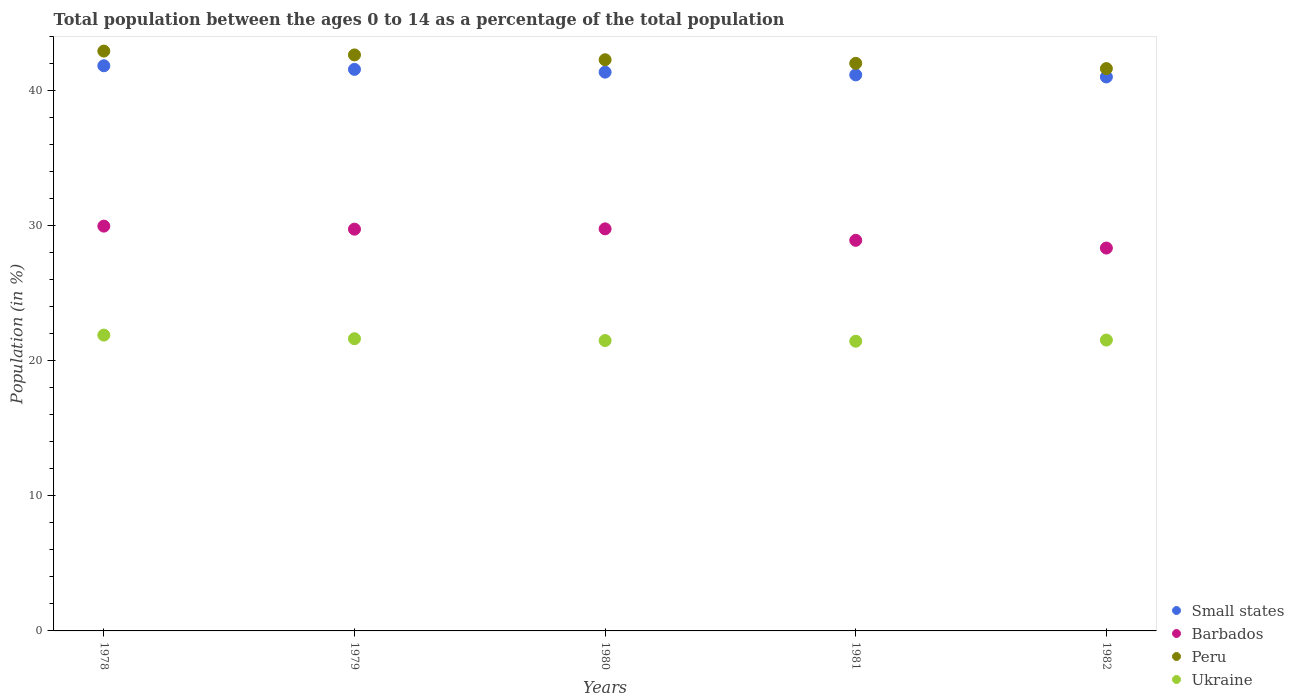How many different coloured dotlines are there?
Provide a short and direct response. 4. What is the percentage of the population ages 0 to 14 in Ukraine in 1981?
Your answer should be very brief. 21.45. Across all years, what is the maximum percentage of the population ages 0 to 14 in Barbados?
Your answer should be very brief. 29.98. Across all years, what is the minimum percentage of the population ages 0 to 14 in Peru?
Ensure brevity in your answer.  41.64. In which year was the percentage of the population ages 0 to 14 in Barbados maximum?
Offer a terse response. 1978. What is the total percentage of the population ages 0 to 14 in Small states in the graph?
Offer a terse response. 207.01. What is the difference between the percentage of the population ages 0 to 14 in Barbados in 1980 and that in 1981?
Offer a terse response. 0.85. What is the difference between the percentage of the population ages 0 to 14 in Small states in 1980 and the percentage of the population ages 0 to 14 in Ukraine in 1982?
Provide a succinct answer. 19.84. What is the average percentage of the population ages 0 to 14 in Peru per year?
Your answer should be very brief. 42.31. In the year 1980, what is the difference between the percentage of the population ages 0 to 14 in Small states and percentage of the population ages 0 to 14 in Peru?
Your answer should be very brief. -0.92. In how many years, is the percentage of the population ages 0 to 14 in Barbados greater than 16?
Provide a short and direct response. 5. What is the ratio of the percentage of the population ages 0 to 14 in Peru in 1980 to that in 1982?
Provide a succinct answer. 1.02. Is the percentage of the population ages 0 to 14 in Ukraine in 1979 less than that in 1980?
Ensure brevity in your answer.  No. Is the difference between the percentage of the population ages 0 to 14 in Small states in 1980 and 1982 greater than the difference between the percentage of the population ages 0 to 14 in Peru in 1980 and 1982?
Make the answer very short. No. What is the difference between the highest and the second highest percentage of the population ages 0 to 14 in Ukraine?
Offer a terse response. 0.27. What is the difference between the highest and the lowest percentage of the population ages 0 to 14 in Barbados?
Make the answer very short. 1.62. Is the sum of the percentage of the population ages 0 to 14 in Small states in 1978 and 1979 greater than the maximum percentage of the population ages 0 to 14 in Ukraine across all years?
Offer a terse response. Yes. Does the percentage of the population ages 0 to 14 in Small states monotonically increase over the years?
Your response must be concise. No. Is the percentage of the population ages 0 to 14 in Barbados strictly greater than the percentage of the population ages 0 to 14 in Ukraine over the years?
Offer a very short reply. Yes. Is the percentage of the population ages 0 to 14 in Peru strictly less than the percentage of the population ages 0 to 14 in Small states over the years?
Your answer should be compact. No. How many dotlines are there?
Ensure brevity in your answer.  4. How many years are there in the graph?
Keep it short and to the point. 5. What is the difference between two consecutive major ticks on the Y-axis?
Your answer should be compact. 10. Does the graph contain any zero values?
Offer a terse response. No. What is the title of the graph?
Your answer should be very brief. Total population between the ages 0 to 14 as a percentage of the total population. What is the label or title of the X-axis?
Offer a very short reply. Years. What is the label or title of the Y-axis?
Make the answer very short. Population (in %). What is the Population (in %) of Small states in 1978?
Your answer should be very brief. 41.85. What is the Population (in %) of Barbados in 1978?
Your answer should be compact. 29.98. What is the Population (in %) in Peru in 1978?
Provide a succinct answer. 42.94. What is the Population (in %) of Ukraine in 1978?
Your answer should be compact. 21.91. What is the Population (in %) in Small states in 1979?
Your response must be concise. 41.58. What is the Population (in %) in Barbados in 1979?
Offer a very short reply. 29.75. What is the Population (in %) of Peru in 1979?
Provide a succinct answer. 42.65. What is the Population (in %) of Ukraine in 1979?
Ensure brevity in your answer.  21.64. What is the Population (in %) in Small states in 1980?
Your answer should be compact. 41.38. What is the Population (in %) of Barbados in 1980?
Provide a short and direct response. 29.77. What is the Population (in %) of Peru in 1980?
Your response must be concise. 42.3. What is the Population (in %) in Ukraine in 1980?
Ensure brevity in your answer.  21.5. What is the Population (in %) in Small states in 1981?
Your response must be concise. 41.18. What is the Population (in %) in Barbados in 1981?
Make the answer very short. 28.92. What is the Population (in %) in Peru in 1981?
Give a very brief answer. 42.03. What is the Population (in %) of Ukraine in 1981?
Ensure brevity in your answer.  21.45. What is the Population (in %) of Small states in 1982?
Make the answer very short. 41.02. What is the Population (in %) in Barbados in 1982?
Your answer should be very brief. 28.35. What is the Population (in %) of Peru in 1982?
Your answer should be very brief. 41.64. What is the Population (in %) of Ukraine in 1982?
Provide a short and direct response. 21.54. Across all years, what is the maximum Population (in %) in Small states?
Provide a short and direct response. 41.85. Across all years, what is the maximum Population (in %) in Barbados?
Your answer should be very brief. 29.98. Across all years, what is the maximum Population (in %) in Peru?
Keep it short and to the point. 42.94. Across all years, what is the maximum Population (in %) of Ukraine?
Ensure brevity in your answer.  21.91. Across all years, what is the minimum Population (in %) of Small states?
Your answer should be very brief. 41.02. Across all years, what is the minimum Population (in %) in Barbados?
Your answer should be very brief. 28.35. Across all years, what is the minimum Population (in %) of Peru?
Ensure brevity in your answer.  41.64. Across all years, what is the minimum Population (in %) of Ukraine?
Provide a short and direct response. 21.45. What is the total Population (in %) in Small states in the graph?
Your answer should be compact. 207.01. What is the total Population (in %) of Barbados in the graph?
Make the answer very short. 146.78. What is the total Population (in %) of Peru in the graph?
Offer a very short reply. 211.56. What is the total Population (in %) in Ukraine in the graph?
Offer a very short reply. 108.04. What is the difference between the Population (in %) in Small states in 1978 and that in 1979?
Your answer should be very brief. 0.27. What is the difference between the Population (in %) in Barbados in 1978 and that in 1979?
Your response must be concise. 0.23. What is the difference between the Population (in %) of Peru in 1978 and that in 1979?
Your response must be concise. 0.28. What is the difference between the Population (in %) of Ukraine in 1978 and that in 1979?
Your answer should be compact. 0.27. What is the difference between the Population (in %) in Small states in 1978 and that in 1980?
Offer a terse response. 0.47. What is the difference between the Population (in %) in Barbados in 1978 and that in 1980?
Your answer should be compact. 0.2. What is the difference between the Population (in %) in Peru in 1978 and that in 1980?
Make the answer very short. 0.64. What is the difference between the Population (in %) of Ukraine in 1978 and that in 1980?
Give a very brief answer. 0.4. What is the difference between the Population (in %) in Small states in 1978 and that in 1981?
Make the answer very short. 0.68. What is the difference between the Population (in %) of Barbados in 1978 and that in 1981?
Offer a very short reply. 1.05. What is the difference between the Population (in %) of Peru in 1978 and that in 1981?
Your response must be concise. 0.91. What is the difference between the Population (in %) of Ukraine in 1978 and that in 1981?
Provide a short and direct response. 0.45. What is the difference between the Population (in %) in Small states in 1978 and that in 1982?
Give a very brief answer. 0.83. What is the difference between the Population (in %) in Barbados in 1978 and that in 1982?
Ensure brevity in your answer.  1.62. What is the difference between the Population (in %) of Peru in 1978 and that in 1982?
Your answer should be very brief. 1.3. What is the difference between the Population (in %) in Ukraine in 1978 and that in 1982?
Your response must be concise. 0.37. What is the difference between the Population (in %) of Small states in 1979 and that in 1980?
Make the answer very short. 0.2. What is the difference between the Population (in %) in Barbados in 1979 and that in 1980?
Offer a very short reply. -0.02. What is the difference between the Population (in %) of Peru in 1979 and that in 1980?
Keep it short and to the point. 0.36. What is the difference between the Population (in %) in Ukraine in 1979 and that in 1980?
Your response must be concise. 0.14. What is the difference between the Population (in %) in Small states in 1979 and that in 1981?
Ensure brevity in your answer.  0.41. What is the difference between the Population (in %) in Barbados in 1979 and that in 1981?
Give a very brief answer. 0.83. What is the difference between the Population (in %) in Peru in 1979 and that in 1981?
Your answer should be compact. 0.62. What is the difference between the Population (in %) in Ukraine in 1979 and that in 1981?
Offer a terse response. 0.18. What is the difference between the Population (in %) of Small states in 1979 and that in 1982?
Provide a succinct answer. 0.56. What is the difference between the Population (in %) in Barbados in 1979 and that in 1982?
Offer a very short reply. 1.4. What is the difference between the Population (in %) of Peru in 1979 and that in 1982?
Your answer should be compact. 1.01. What is the difference between the Population (in %) of Ukraine in 1979 and that in 1982?
Your answer should be compact. 0.1. What is the difference between the Population (in %) in Small states in 1980 and that in 1981?
Offer a terse response. 0.2. What is the difference between the Population (in %) in Barbados in 1980 and that in 1981?
Provide a succinct answer. 0.85. What is the difference between the Population (in %) in Peru in 1980 and that in 1981?
Keep it short and to the point. 0.26. What is the difference between the Population (in %) in Ukraine in 1980 and that in 1981?
Your response must be concise. 0.05. What is the difference between the Population (in %) of Small states in 1980 and that in 1982?
Ensure brevity in your answer.  0.36. What is the difference between the Population (in %) of Barbados in 1980 and that in 1982?
Give a very brief answer. 1.42. What is the difference between the Population (in %) of Peru in 1980 and that in 1982?
Offer a very short reply. 0.65. What is the difference between the Population (in %) of Ukraine in 1980 and that in 1982?
Your answer should be compact. -0.04. What is the difference between the Population (in %) in Small states in 1981 and that in 1982?
Give a very brief answer. 0.15. What is the difference between the Population (in %) of Barbados in 1981 and that in 1982?
Keep it short and to the point. 0.57. What is the difference between the Population (in %) of Peru in 1981 and that in 1982?
Give a very brief answer. 0.39. What is the difference between the Population (in %) of Ukraine in 1981 and that in 1982?
Offer a terse response. -0.09. What is the difference between the Population (in %) of Small states in 1978 and the Population (in %) of Barbados in 1979?
Your response must be concise. 12.1. What is the difference between the Population (in %) of Small states in 1978 and the Population (in %) of Peru in 1979?
Make the answer very short. -0.8. What is the difference between the Population (in %) of Small states in 1978 and the Population (in %) of Ukraine in 1979?
Ensure brevity in your answer.  20.21. What is the difference between the Population (in %) in Barbados in 1978 and the Population (in %) in Peru in 1979?
Your response must be concise. -12.68. What is the difference between the Population (in %) of Barbados in 1978 and the Population (in %) of Ukraine in 1979?
Ensure brevity in your answer.  8.34. What is the difference between the Population (in %) of Peru in 1978 and the Population (in %) of Ukraine in 1979?
Provide a short and direct response. 21.3. What is the difference between the Population (in %) of Small states in 1978 and the Population (in %) of Barbados in 1980?
Keep it short and to the point. 12.08. What is the difference between the Population (in %) in Small states in 1978 and the Population (in %) in Peru in 1980?
Make the answer very short. -0.44. What is the difference between the Population (in %) of Small states in 1978 and the Population (in %) of Ukraine in 1980?
Your response must be concise. 20.35. What is the difference between the Population (in %) in Barbados in 1978 and the Population (in %) in Peru in 1980?
Keep it short and to the point. -12.32. What is the difference between the Population (in %) in Barbados in 1978 and the Population (in %) in Ukraine in 1980?
Offer a terse response. 8.47. What is the difference between the Population (in %) in Peru in 1978 and the Population (in %) in Ukraine in 1980?
Make the answer very short. 21.44. What is the difference between the Population (in %) in Small states in 1978 and the Population (in %) in Barbados in 1981?
Offer a very short reply. 12.93. What is the difference between the Population (in %) in Small states in 1978 and the Population (in %) in Peru in 1981?
Give a very brief answer. -0.18. What is the difference between the Population (in %) in Small states in 1978 and the Population (in %) in Ukraine in 1981?
Your answer should be compact. 20.4. What is the difference between the Population (in %) of Barbados in 1978 and the Population (in %) of Peru in 1981?
Your response must be concise. -12.06. What is the difference between the Population (in %) of Barbados in 1978 and the Population (in %) of Ukraine in 1981?
Provide a short and direct response. 8.52. What is the difference between the Population (in %) in Peru in 1978 and the Population (in %) in Ukraine in 1981?
Offer a terse response. 21.49. What is the difference between the Population (in %) in Small states in 1978 and the Population (in %) in Barbados in 1982?
Your response must be concise. 13.5. What is the difference between the Population (in %) of Small states in 1978 and the Population (in %) of Peru in 1982?
Your response must be concise. 0.21. What is the difference between the Population (in %) of Small states in 1978 and the Population (in %) of Ukraine in 1982?
Keep it short and to the point. 20.31. What is the difference between the Population (in %) of Barbados in 1978 and the Population (in %) of Peru in 1982?
Ensure brevity in your answer.  -11.67. What is the difference between the Population (in %) of Barbados in 1978 and the Population (in %) of Ukraine in 1982?
Your answer should be compact. 8.44. What is the difference between the Population (in %) in Peru in 1978 and the Population (in %) in Ukraine in 1982?
Make the answer very short. 21.4. What is the difference between the Population (in %) of Small states in 1979 and the Population (in %) of Barbados in 1980?
Give a very brief answer. 11.81. What is the difference between the Population (in %) of Small states in 1979 and the Population (in %) of Peru in 1980?
Keep it short and to the point. -0.71. What is the difference between the Population (in %) in Small states in 1979 and the Population (in %) in Ukraine in 1980?
Make the answer very short. 20.08. What is the difference between the Population (in %) in Barbados in 1979 and the Population (in %) in Peru in 1980?
Offer a terse response. -12.55. What is the difference between the Population (in %) in Barbados in 1979 and the Population (in %) in Ukraine in 1980?
Your response must be concise. 8.25. What is the difference between the Population (in %) in Peru in 1979 and the Population (in %) in Ukraine in 1980?
Provide a short and direct response. 21.15. What is the difference between the Population (in %) of Small states in 1979 and the Population (in %) of Barbados in 1981?
Make the answer very short. 12.66. What is the difference between the Population (in %) of Small states in 1979 and the Population (in %) of Peru in 1981?
Give a very brief answer. -0.45. What is the difference between the Population (in %) of Small states in 1979 and the Population (in %) of Ukraine in 1981?
Your answer should be very brief. 20.13. What is the difference between the Population (in %) of Barbados in 1979 and the Population (in %) of Peru in 1981?
Ensure brevity in your answer.  -12.28. What is the difference between the Population (in %) of Barbados in 1979 and the Population (in %) of Ukraine in 1981?
Offer a terse response. 8.3. What is the difference between the Population (in %) of Peru in 1979 and the Population (in %) of Ukraine in 1981?
Keep it short and to the point. 21.2. What is the difference between the Population (in %) in Small states in 1979 and the Population (in %) in Barbados in 1982?
Offer a terse response. 13.23. What is the difference between the Population (in %) of Small states in 1979 and the Population (in %) of Peru in 1982?
Offer a very short reply. -0.06. What is the difference between the Population (in %) in Small states in 1979 and the Population (in %) in Ukraine in 1982?
Your answer should be compact. 20.04. What is the difference between the Population (in %) in Barbados in 1979 and the Population (in %) in Peru in 1982?
Provide a short and direct response. -11.89. What is the difference between the Population (in %) in Barbados in 1979 and the Population (in %) in Ukraine in 1982?
Provide a succinct answer. 8.21. What is the difference between the Population (in %) of Peru in 1979 and the Population (in %) of Ukraine in 1982?
Provide a succinct answer. 21.12. What is the difference between the Population (in %) of Small states in 1980 and the Population (in %) of Barbados in 1981?
Make the answer very short. 12.45. What is the difference between the Population (in %) in Small states in 1980 and the Population (in %) in Peru in 1981?
Make the answer very short. -0.65. What is the difference between the Population (in %) of Small states in 1980 and the Population (in %) of Ukraine in 1981?
Your answer should be very brief. 19.93. What is the difference between the Population (in %) of Barbados in 1980 and the Population (in %) of Peru in 1981?
Your answer should be compact. -12.26. What is the difference between the Population (in %) in Barbados in 1980 and the Population (in %) in Ukraine in 1981?
Provide a succinct answer. 8.32. What is the difference between the Population (in %) of Peru in 1980 and the Population (in %) of Ukraine in 1981?
Offer a terse response. 20.84. What is the difference between the Population (in %) in Small states in 1980 and the Population (in %) in Barbados in 1982?
Offer a very short reply. 13.03. What is the difference between the Population (in %) in Small states in 1980 and the Population (in %) in Peru in 1982?
Offer a very short reply. -0.26. What is the difference between the Population (in %) in Small states in 1980 and the Population (in %) in Ukraine in 1982?
Offer a very short reply. 19.84. What is the difference between the Population (in %) of Barbados in 1980 and the Population (in %) of Peru in 1982?
Your answer should be compact. -11.87. What is the difference between the Population (in %) of Barbados in 1980 and the Population (in %) of Ukraine in 1982?
Provide a succinct answer. 8.24. What is the difference between the Population (in %) of Peru in 1980 and the Population (in %) of Ukraine in 1982?
Your response must be concise. 20.76. What is the difference between the Population (in %) of Small states in 1981 and the Population (in %) of Barbados in 1982?
Keep it short and to the point. 12.82. What is the difference between the Population (in %) in Small states in 1981 and the Population (in %) in Peru in 1982?
Your answer should be compact. -0.47. What is the difference between the Population (in %) of Small states in 1981 and the Population (in %) of Ukraine in 1982?
Your answer should be compact. 19.64. What is the difference between the Population (in %) in Barbados in 1981 and the Population (in %) in Peru in 1982?
Your answer should be compact. -12.72. What is the difference between the Population (in %) of Barbados in 1981 and the Population (in %) of Ukraine in 1982?
Keep it short and to the point. 7.39. What is the difference between the Population (in %) of Peru in 1981 and the Population (in %) of Ukraine in 1982?
Provide a short and direct response. 20.49. What is the average Population (in %) of Small states per year?
Your response must be concise. 41.4. What is the average Population (in %) in Barbados per year?
Your answer should be compact. 29.36. What is the average Population (in %) in Peru per year?
Your answer should be very brief. 42.31. What is the average Population (in %) of Ukraine per year?
Your answer should be compact. 21.61. In the year 1978, what is the difference between the Population (in %) in Small states and Population (in %) in Barbados?
Ensure brevity in your answer.  11.88. In the year 1978, what is the difference between the Population (in %) in Small states and Population (in %) in Peru?
Your answer should be compact. -1.09. In the year 1978, what is the difference between the Population (in %) of Small states and Population (in %) of Ukraine?
Your answer should be compact. 19.95. In the year 1978, what is the difference between the Population (in %) in Barbados and Population (in %) in Peru?
Provide a short and direct response. -12.96. In the year 1978, what is the difference between the Population (in %) in Barbados and Population (in %) in Ukraine?
Offer a terse response. 8.07. In the year 1978, what is the difference between the Population (in %) in Peru and Population (in %) in Ukraine?
Give a very brief answer. 21.03. In the year 1979, what is the difference between the Population (in %) of Small states and Population (in %) of Barbados?
Give a very brief answer. 11.83. In the year 1979, what is the difference between the Population (in %) in Small states and Population (in %) in Peru?
Ensure brevity in your answer.  -1.07. In the year 1979, what is the difference between the Population (in %) in Small states and Population (in %) in Ukraine?
Offer a terse response. 19.95. In the year 1979, what is the difference between the Population (in %) in Barbados and Population (in %) in Peru?
Provide a short and direct response. -12.9. In the year 1979, what is the difference between the Population (in %) of Barbados and Population (in %) of Ukraine?
Your response must be concise. 8.11. In the year 1979, what is the difference between the Population (in %) of Peru and Population (in %) of Ukraine?
Provide a short and direct response. 21.02. In the year 1980, what is the difference between the Population (in %) in Small states and Population (in %) in Barbados?
Provide a short and direct response. 11.6. In the year 1980, what is the difference between the Population (in %) in Small states and Population (in %) in Peru?
Make the answer very short. -0.92. In the year 1980, what is the difference between the Population (in %) of Small states and Population (in %) of Ukraine?
Your answer should be very brief. 19.88. In the year 1980, what is the difference between the Population (in %) in Barbados and Population (in %) in Peru?
Your response must be concise. -12.52. In the year 1980, what is the difference between the Population (in %) of Barbados and Population (in %) of Ukraine?
Offer a terse response. 8.27. In the year 1980, what is the difference between the Population (in %) of Peru and Population (in %) of Ukraine?
Your response must be concise. 20.79. In the year 1981, what is the difference between the Population (in %) of Small states and Population (in %) of Barbados?
Provide a short and direct response. 12.25. In the year 1981, what is the difference between the Population (in %) in Small states and Population (in %) in Peru?
Give a very brief answer. -0.86. In the year 1981, what is the difference between the Population (in %) of Small states and Population (in %) of Ukraine?
Your response must be concise. 19.72. In the year 1981, what is the difference between the Population (in %) in Barbados and Population (in %) in Peru?
Your answer should be compact. -13.11. In the year 1981, what is the difference between the Population (in %) of Barbados and Population (in %) of Ukraine?
Offer a terse response. 7.47. In the year 1981, what is the difference between the Population (in %) of Peru and Population (in %) of Ukraine?
Your answer should be compact. 20.58. In the year 1982, what is the difference between the Population (in %) in Small states and Population (in %) in Barbados?
Your answer should be very brief. 12.67. In the year 1982, what is the difference between the Population (in %) of Small states and Population (in %) of Peru?
Ensure brevity in your answer.  -0.62. In the year 1982, what is the difference between the Population (in %) in Small states and Population (in %) in Ukraine?
Offer a very short reply. 19.48. In the year 1982, what is the difference between the Population (in %) of Barbados and Population (in %) of Peru?
Offer a very short reply. -13.29. In the year 1982, what is the difference between the Population (in %) of Barbados and Population (in %) of Ukraine?
Provide a succinct answer. 6.81. In the year 1982, what is the difference between the Population (in %) in Peru and Population (in %) in Ukraine?
Keep it short and to the point. 20.1. What is the ratio of the Population (in %) of Barbados in 1978 to that in 1979?
Make the answer very short. 1.01. What is the ratio of the Population (in %) in Ukraine in 1978 to that in 1979?
Give a very brief answer. 1.01. What is the ratio of the Population (in %) of Small states in 1978 to that in 1980?
Provide a succinct answer. 1.01. What is the ratio of the Population (in %) of Barbados in 1978 to that in 1980?
Make the answer very short. 1.01. What is the ratio of the Population (in %) of Peru in 1978 to that in 1980?
Offer a very short reply. 1.02. What is the ratio of the Population (in %) of Ukraine in 1978 to that in 1980?
Offer a terse response. 1.02. What is the ratio of the Population (in %) of Small states in 1978 to that in 1981?
Offer a terse response. 1.02. What is the ratio of the Population (in %) of Barbados in 1978 to that in 1981?
Your answer should be very brief. 1.04. What is the ratio of the Population (in %) in Peru in 1978 to that in 1981?
Your answer should be compact. 1.02. What is the ratio of the Population (in %) of Ukraine in 1978 to that in 1981?
Make the answer very short. 1.02. What is the ratio of the Population (in %) of Small states in 1978 to that in 1982?
Provide a succinct answer. 1.02. What is the ratio of the Population (in %) of Barbados in 1978 to that in 1982?
Offer a terse response. 1.06. What is the ratio of the Population (in %) in Peru in 1978 to that in 1982?
Ensure brevity in your answer.  1.03. What is the ratio of the Population (in %) of Ukraine in 1978 to that in 1982?
Keep it short and to the point. 1.02. What is the ratio of the Population (in %) in Peru in 1979 to that in 1980?
Your answer should be very brief. 1.01. What is the ratio of the Population (in %) in Ukraine in 1979 to that in 1980?
Provide a short and direct response. 1.01. What is the ratio of the Population (in %) of Small states in 1979 to that in 1981?
Give a very brief answer. 1.01. What is the ratio of the Population (in %) in Barbados in 1979 to that in 1981?
Your answer should be compact. 1.03. What is the ratio of the Population (in %) in Peru in 1979 to that in 1981?
Your answer should be compact. 1.01. What is the ratio of the Population (in %) of Ukraine in 1979 to that in 1981?
Offer a very short reply. 1.01. What is the ratio of the Population (in %) of Small states in 1979 to that in 1982?
Provide a succinct answer. 1.01. What is the ratio of the Population (in %) in Barbados in 1979 to that in 1982?
Offer a very short reply. 1.05. What is the ratio of the Population (in %) of Peru in 1979 to that in 1982?
Give a very brief answer. 1.02. What is the ratio of the Population (in %) in Ukraine in 1979 to that in 1982?
Offer a terse response. 1. What is the ratio of the Population (in %) of Barbados in 1980 to that in 1981?
Your response must be concise. 1.03. What is the ratio of the Population (in %) in Peru in 1980 to that in 1981?
Give a very brief answer. 1.01. What is the ratio of the Population (in %) of Ukraine in 1980 to that in 1981?
Provide a succinct answer. 1. What is the ratio of the Population (in %) of Small states in 1980 to that in 1982?
Ensure brevity in your answer.  1.01. What is the ratio of the Population (in %) in Barbados in 1980 to that in 1982?
Provide a succinct answer. 1.05. What is the ratio of the Population (in %) in Peru in 1980 to that in 1982?
Your answer should be compact. 1.02. What is the ratio of the Population (in %) in Ukraine in 1980 to that in 1982?
Provide a short and direct response. 1. What is the ratio of the Population (in %) of Small states in 1981 to that in 1982?
Provide a short and direct response. 1. What is the ratio of the Population (in %) in Barbados in 1981 to that in 1982?
Provide a succinct answer. 1.02. What is the ratio of the Population (in %) of Peru in 1981 to that in 1982?
Offer a terse response. 1.01. What is the difference between the highest and the second highest Population (in %) of Small states?
Provide a succinct answer. 0.27. What is the difference between the highest and the second highest Population (in %) of Barbados?
Offer a terse response. 0.2. What is the difference between the highest and the second highest Population (in %) in Peru?
Keep it short and to the point. 0.28. What is the difference between the highest and the second highest Population (in %) of Ukraine?
Your response must be concise. 0.27. What is the difference between the highest and the lowest Population (in %) in Small states?
Provide a succinct answer. 0.83. What is the difference between the highest and the lowest Population (in %) of Barbados?
Your response must be concise. 1.62. What is the difference between the highest and the lowest Population (in %) of Peru?
Offer a very short reply. 1.3. What is the difference between the highest and the lowest Population (in %) of Ukraine?
Provide a short and direct response. 0.45. 